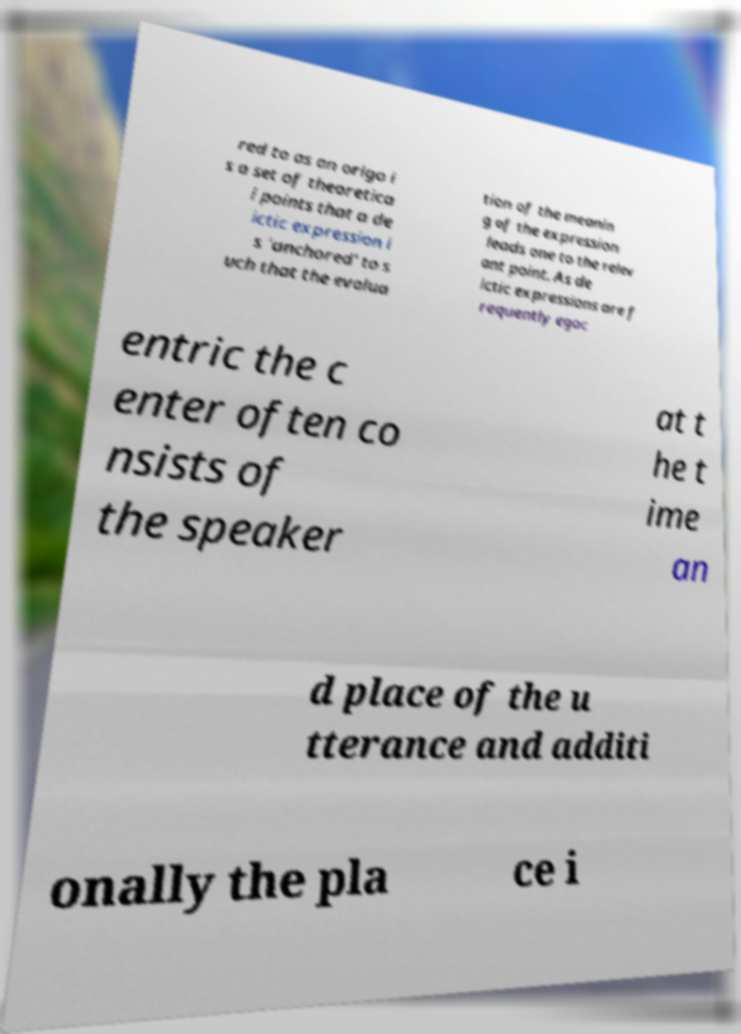Could you assist in decoding the text presented in this image and type it out clearly? red to as an origo i s a set of theoretica l points that a de ictic expression i s 'anchored' to s uch that the evalua tion of the meanin g of the expression leads one to the relev ant point. As de ictic expressions are f requently egoc entric the c enter often co nsists of the speaker at t he t ime an d place of the u tterance and additi onally the pla ce i 